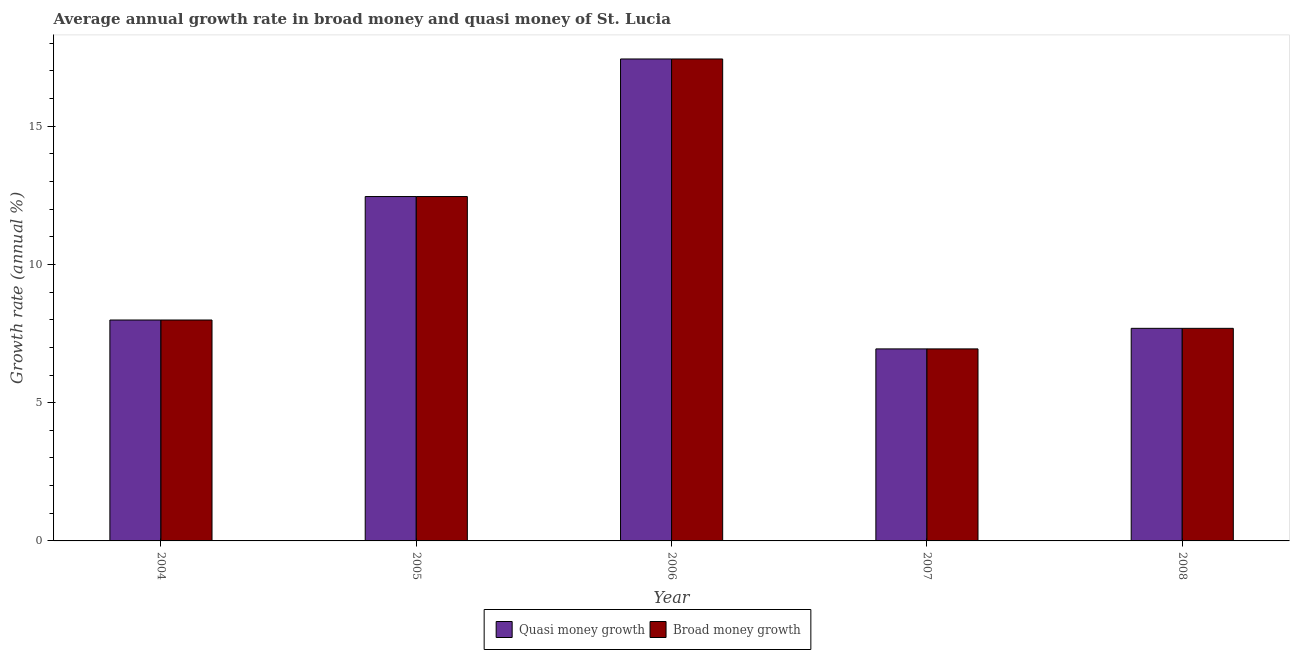How many different coloured bars are there?
Your answer should be very brief. 2. Are the number of bars per tick equal to the number of legend labels?
Ensure brevity in your answer.  Yes. Are the number of bars on each tick of the X-axis equal?
Provide a short and direct response. Yes. In how many cases, is the number of bars for a given year not equal to the number of legend labels?
Provide a short and direct response. 0. What is the annual growth rate in quasi money in 2006?
Ensure brevity in your answer.  17.43. Across all years, what is the maximum annual growth rate in quasi money?
Make the answer very short. 17.43. Across all years, what is the minimum annual growth rate in broad money?
Offer a terse response. 6.95. What is the total annual growth rate in broad money in the graph?
Offer a very short reply. 52.51. What is the difference between the annual growth rate in broad money in 2006 and that in 2008?
Your response must be concise. 9.74. What is the difference between the annual growth rate in broad money in 2008 and the annual growth rate in quasi money in 2007?
Make the answer very short. 0.74. What is the average annual growth rate in quasi money per year?
Ensure brevity in your answer.  10.5. What is the ratio of the annual growth rate in broad money in 2004 to that in 2008?
Give a very brief answer. 1.04. Is the annual growth rate in quasi money in 2005 less than that in 2008?
Offer a very short reply. No. What is the difference between the highest and the second highest annual growth rate in quasi money?
Your response must be concise. 4.98. What is the difference between the highest and the lowest annual growth rate in quasi money?
Your answer should be compact. 10.49. In how many years, is the annual growth rate in broad money greater than the average annual growth rate in broad money taken over all years?
Ensure brevity in your answer.  2. What does the 2nd bar from the left in 2008 represents?
Provide a short and direct response. Broad money growth. What does the 2nd bar from the right in 2006 represents?
Provide a short and direct response. Quasi money growth. Are all the bars in the graph horizontal?
Give a very brief answer. No. Does the graph contain any zero values?
Offer a very short reply. No. How many legend labels are there?
Your response must be concise. 2. How are the legend labels stacked?
Your response must be concise. Horizontal. What is the title of the graph?
Keep it short and to the point. Average annual growth rate in broad money and quasi money of St. Lucia. Does "Taxes on exports" appear as one of the legend labels in the graph?
Provide a succinct answer. No. What is the label or title of the Y-axis?
Offer a very short reply. Growth rate (annual %). What is the Growth rate (annual %) of Quasi money growth in 2004?
Offer a very short reply. 7.99. What is the Growth rate (annual %) in Broad money growth in 2004?
Provide a short and direct response. 7.99. What is the Growth rate (annual %) of Quasi money growth in 2005?
Offer a terse response. 12.46. What is the Growth rate (annual %) of Broad money growth in 2005?
Keep it short and to the point. 12.46. What is the Growth rate (annual %) in Quasi money growth in 2006?
Keep it short and to the point. 17.43. What is the Growth rate (annual %) in Broad money growth in 2006?
Give a very brief answer. 17.43. What is the Growth rate (annual %) in Quasi money growth in 2007?
Make the answer very short. 6.95. What is the Growth rate (annual %) in Broad money growth in 2007?
Ensure brevity in your answer.  6.95. What is the Growth rate (annual %) of Quasi money growth in 2008?
Make the answer very short. 7.69. What is the Growth rate (annual %) of Broad money growth in 2008?
Your answer should be very brief. 7.69. Across all years, what is the maximum Growth rate (annual %) of Quasi money growth?
Keep it short and to the point. 17.43. Across all years, what is the maximum Growth rate (annual %) of Broad money growth?
Offer a terse response. 17.43. Across all years, what is the minimum Growth rate (annual %) in Quasi money growth?
Keep it short and to the point. 6.95. Across all years, what is the minimum Growth rate (annual %) of Broad money growth?
Your answer should be very brief. 6.95. What is the total Growth rate (annual %) of Quasi money growth in the graph?
Your answer should be compact. 52.51. What is the total Growth rate (annual %) of Broad money growth in the graph?
Provide a succinct answer. 52.51. What is the difference between the Growth rate (annual %) in Quasi money growth in 2004 and that in 2005?
Your response must be concise. -4.47. What is the difference between the Growth rate (annual %) in Broad money growth in 2004 and that in 2005?
Keep it short and to the point. -4.47. What is the difference between the Growth rate (annual %) in Quasi money growth in 2004 and that in 2006?
Your answer should be compact. -9.44. What is the difference between the Growth rate (annual %) in Broad money growth in 2004 and that in 2006?
Keep it short and to the point. -9.44. What is the difference between the Growth rate (annual %) in Quasi money growth in 2004 and that in 2007?
Make the answer very short. 1.05. What is the difference between the Growth rate (annual %) of Broad money growth in 2004 and that in 2007?
Provide a succinct answer. 1.05. What is the difference between the Growth rate (annual %) of Quasi money growth in 2004 and that in 2008?
Your answer should be compact. 0.3. What is the difference between the Growth rate (annual %) in Broad money growth in 2004 and that in 2008?
Offer a terse response. 0.3. What is the difference between the Growth rate (annual %) of Quasi money growth in 2005 and that in 2006?
Your answer should be compact. -4.98. What is the difference between the Growth rate (annual %) in Broad money growth in 2005 and that in 2006?
Give a very brief answer. -4.98. What is the difference between the Growth rate (annual %) of Quasi money growth in 2005 and that in 2007?
Provide a short and direct response. 5.51. What is the difference between the Growth rate (annual %) of Broad money growth in 2005 and that in 2007?
Your answer should be compact. 5.51. What is the difference between the Growth rate (annual %) of Quasi money growth in 2005 and that in 2008?
Keep it short and to the point. 4.77. What is the difference between the Growth rate (annual %) in Broad money growth in 2005 and that in 2008?
Offer a terse response. 4.77. What is the difference between the Growth rate (annual %) in Quasi money growth in 2006 and that in 2007?
Your response must be concise. 10.49. What is the difference between the Growth rate (annual %) in Broad money growth in 2006 and that in 2007?
Your answer should be compact. 10.49. What is the difference between the Growth rate (annual %) in Quasi money growth in 2006 and that in 2008?
Offer a very short reply. 9.74. What is the difference between the Growth rate (annual %) of Broad money growth in 2006 and that in 2008?
Keep it short and to the point. 9.74. What is the difference between the Growth rate (annual %) in Quasi money growth in 2007 and that in 2008?
Provide a succinct answer. -0.74. What is the difference between the Growth rate (annual %) of Broad money growth in 2007 and that in 2008?
Offer a very short reply. -0.74. What is the difference between the Growth rate (annual %) in Quasi money growth in 2004 and the Growth rate (annual %) in Broad money growth in 2005?
Give a very brief answer. -4.47. What is the difference between the Growth rate (annual %) in Quasi money growth in 2004 and the Growth rate (annual %) in Broad money growth in 2006?
Ensure brevity in your answer.  -9.44. What is the difference between the Growth rate (annual %) of Quasi money growth in 2004 and the Growth rate (annual %) of Broad money growth in 2007?
Your answer should be very brief. 1.05. What is the difference between the Growth rate (annual %) in Quasi money growth in 2004 and the Growth rate (annual %) in Broad money growth in 2008?
Offer a very short reply. 0.3. What is the difference between the Growth rate (annual %) of Quasi money growth in 2005 and the Growth rate (annual %) of Broad money growth in 2006?
Your answer should be compact. -4.98. What is the difference between the Growth rate (annual %) in Quasi money growth in 2005 and the Growth rate (annual %) in Broad money growth in 2007?
Offer a terse response. 5.51. What is the difference between the Growth rate (annual %) in Quasi money growth in 2005 and the Growth rate (annual %) in Broad money growth in 2008?
Your response must be concise. 4.77. What is the difference between the Growth rate (annual %) in Quasi money growth in 2006 and the Growth rate (annual %) in Broad money growth in 2007?
Keep it short and to the point. 10.49. What is the difference between the Growth rate (annual %) of Quasi money growth in 2006 and the Growth rate (annual %) of Broad money growth in 2008?
Offer a very short reply. 9.74. What is the difference between the Growth rate (annual %) in Quasi money growth in 2007 and the Growth rate (annual %) in Broad money growth in 2008?
Keep it short and to the point. -0.74. What is the average Growth rate (annual %) of Quasi money growth per year?
Your answer should be very brief. 10.5. What is the average Growth rate (annual %) of Broad money growth per year?
Your answer should be very brief. 10.5. In the year 2004, what is the difference between the Growth rate (annual %) of Quasi money growth and Growth rate (annual %) of Broad money growth?
Offer a very short reply. 0. In the year 2005, what is the difference between the Growth rate (annual %) in Quasi money growth and Growth rate (annual %) in Broad money growth?
Give a very brief answer. 0. In the year 2007, what is the difference between the Growth rate (annual %) of Quasi money growth and Growth rate (annual %) of Broad money growth?
Offer a very short reply. 0. What is the ratio of the Growth rate (annual %) of Quasi money growth in 2004 to that in 2005?
Ensure brevity in your answer.  0.64. What is the ratio of the Growth rate (annual %) in Broad money growth in 2004 to that in 2005?
Your answer should be very brief. 0.64. What is the ratio of the Growth rate (annual %) in Quasi money growth in 2004 to that in 2006?
Offer a terse response. 0.46. What is the ratio of the Growth rate (annual %) in Broad money growth in 2004 to that in 2006?
Your response must be concise. 0.46. What is the ratio of the Growth rate (annual %) in Quasi money growth in 2004 to that in 2007?
Make the answer very short. 1.15. What is the ratio of the Growth rate (annual %) of Broad money growth in 2004 to that in 2007?
Provide a short and direct response. 1.15. What is the ratio of the Growth rate (annual %) of Quasi money growth in 2004 to that in 2008?
Ensure brevity in your answer.  1.04. What is the ratio of the Growth rate (annual %) of Broad money growth in 2004 to that in 2008?
Make the answer very short. 1.04. What is the ratio of the Growth rate (annual %) of Quasi money growth in 2005 to that in 2006?
Give a very brief answer. 0.71. What is the ratio of the Growth rate (annual %) of Broad money growth in 2005 to that in 2006?
Offer a terse response. 0.71. What is the ratio of the Growth rate (annual %) in Quasi money growth in 2005 to that in 2007?
Ensure brevity in your answer.  1.79. What is the ratio of the Growth rate (annual %) of Broad money growth in 2005 to that in 2007?
Your answer should be compact. 1.79. What is the ratio of the Growth rate (annual %) of Quasi money growth in 2005 to that in 2008?
Keep it short and to the point. 1.62. What is the ratio of the Growth rate (annual %) of Broad money growth in 2005 to that in 2008?
Your response must be concise. 1.62. What is the ratio of the Growth rate (annual %) in Quasi money growth in 2006 to that in 2007?
Offer a terse response. 2.51. What is the ratio of the Growth rate (annual %) in Broad money growth in 2006 to that in 2007?
Provide a short and direct response. 2.51. What is the ratio of the Growth rate (annual %) in Quasi money growth in 2006 to that in 2008?
Offer a terse response. 2.27. What is the ratio of the Growth rate (annual %) of Broad money growth in 2006 to that in 2008?
Your answer should be very brief. 2.27. What is the ratio of the Growth rate (annual %) in Quasi money growth in 2007 to that in 2008?
Make the answer very short. 0.9. What is the ratio of the Growth rate (annual %) in Broad money growth in 2007 to that in 2008?
Your answer should be compact. 0.9. What is the difference between the highest and the second highest Growth rate (annual %) of Quasi money growth?
Make the answer very short. 4.98. What is the difference between the highest and the second highest Growth rate (annual %) in Broad money growth?
Your response must be concise. 4.98. What is the difference between the highest and the lowest Growth rate (annual %) in Quasi money growth?
Offer a very short reply. 10.49. What is the difference between the highest and the lowest Growth rate (annual %) in Broad money growth?
Keep it short and to the point. 10.49. 